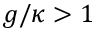<formula> <loc_0><loc_0><loc_500><loc_500>g / \kappa > 1</formula> 